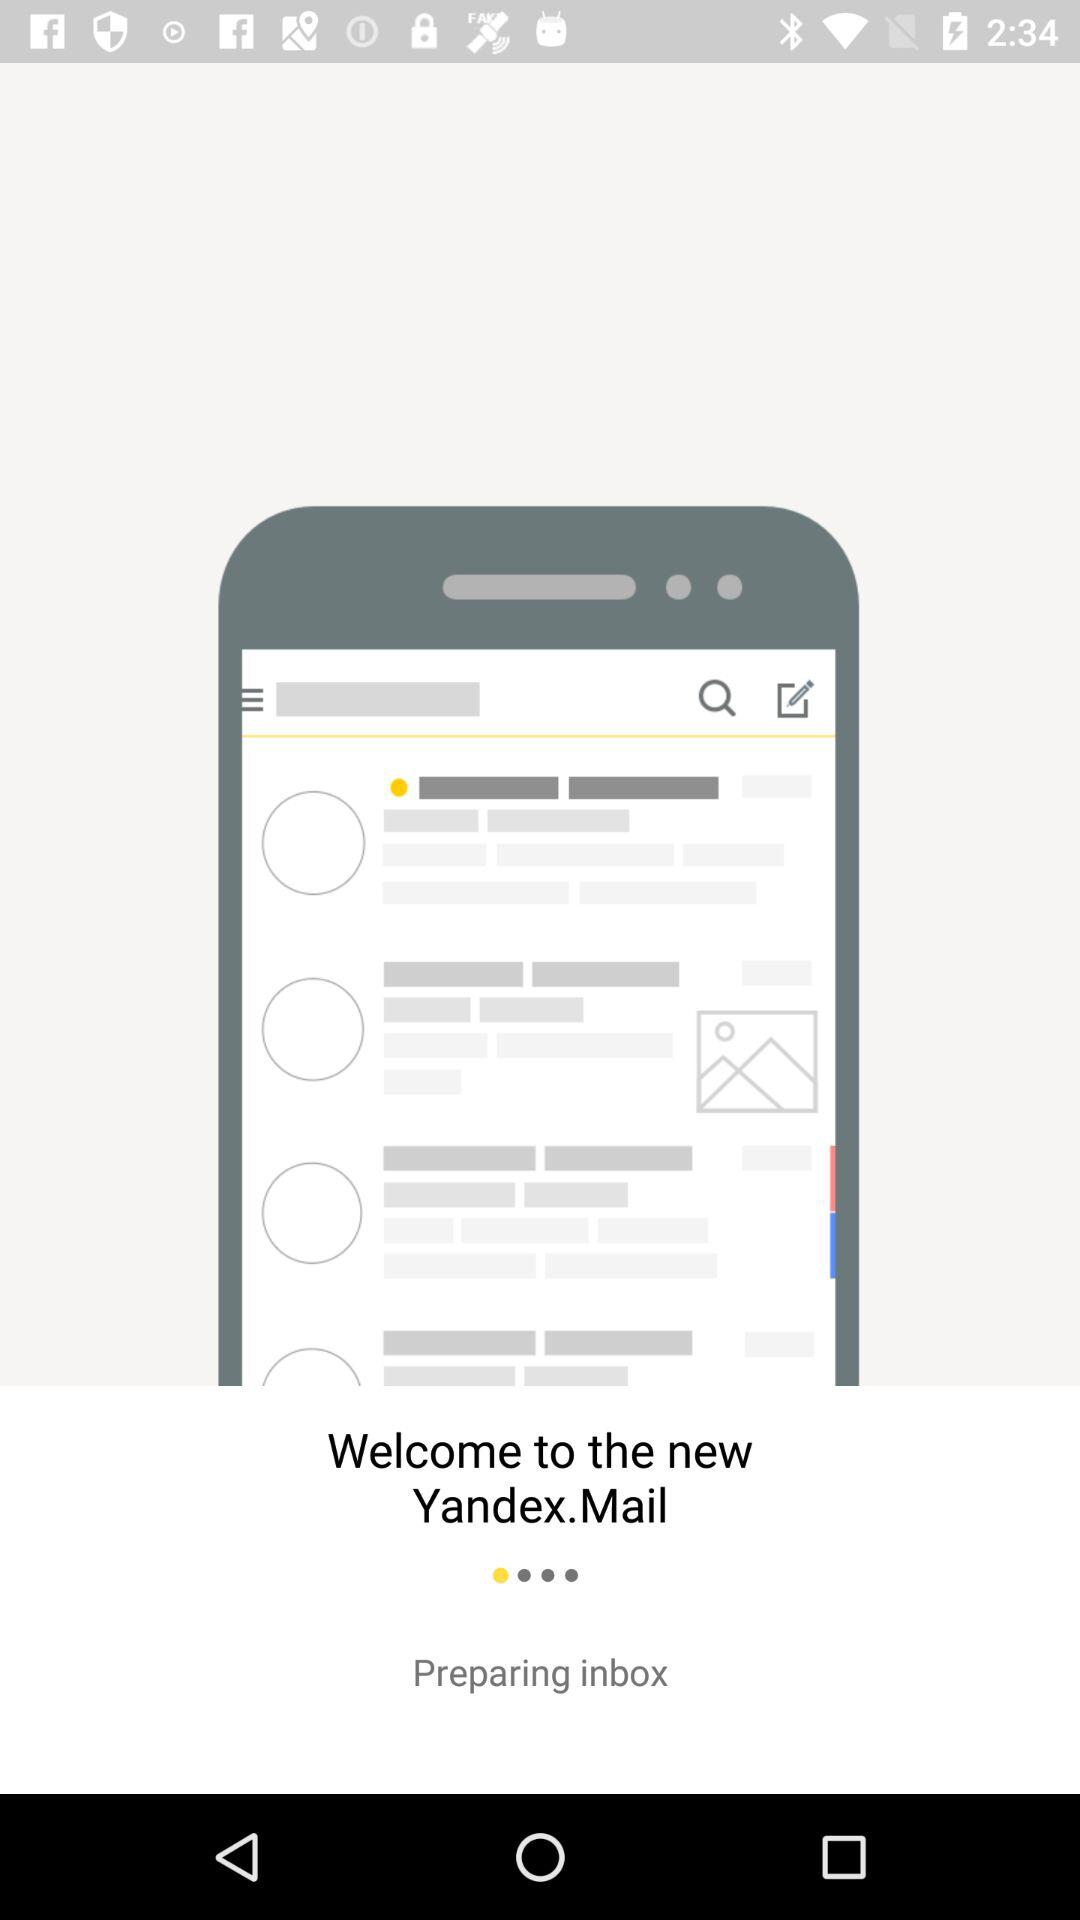What is the application name? The application name is "Yandex.Mail". 